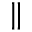Convert formula to latex. <formula><loc_0><loc_0><loc_500><loc_500>\|</formula> 